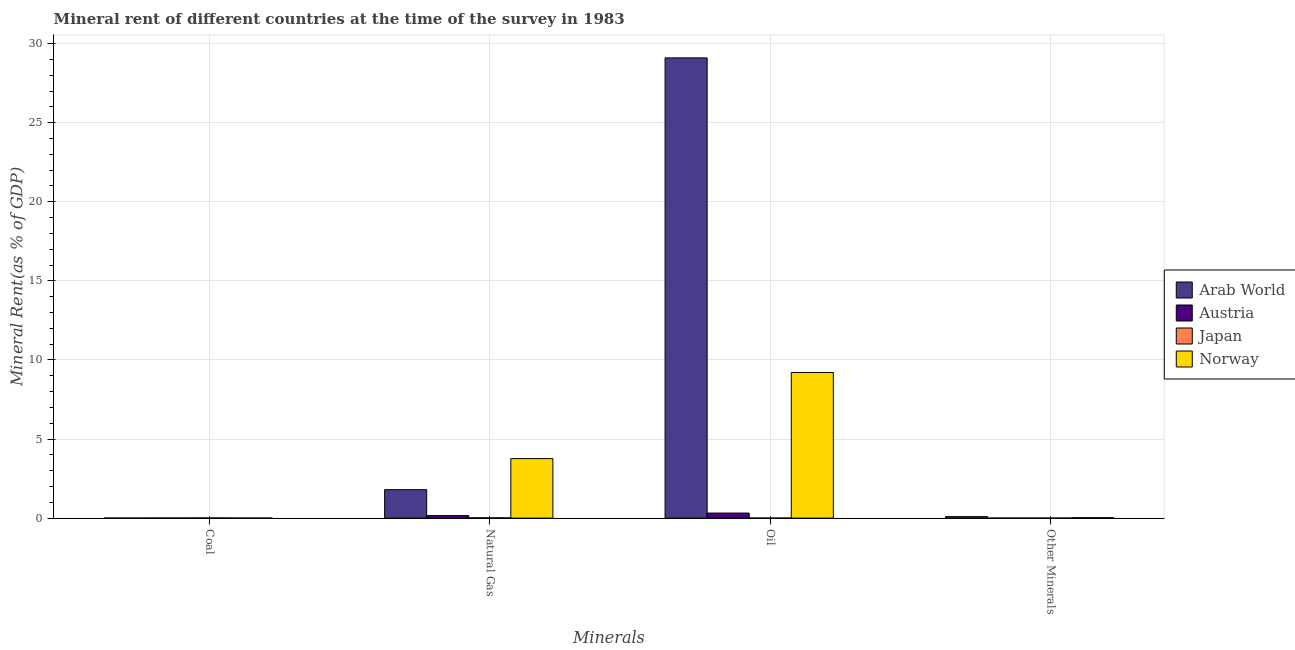How many groups of bars are there?
Give a very brief answer. 4. Are the number of bars on each tick of the X-axis equal?
Give a very brief answer. Yes. How many bars are there on the 1st tick from the right?
Offer a terse response. 4. What is the label of the 4th group of bars from the left?
Your answer should be very brief. Other Minerals. What is the  rent of other minerals in Japan?
Give a very brief answer. 0. Across all countries, what is the maximum oil rent?
Provide a succinct answer. 29.1. Across all countries, what is the minimum  rent of other minerals?
Provide a succinct answer. 0. In which country was the oil rent maximum?
Your answer should be compact. Arab World. What is the total  rent of other minerals in the graph?
Give a very brief answer. 0.13. What is the difference between the oil rent in Japan and that in Arab World?
Offer a very short reply. -29.1. What is the difference between the  rent of other minerals in Arab World and the natural gas rent in Austria?
Give a very brief answer. -0.06. What is the average natural gas rent per country?
Your answer should be very brief. 1.43. What is the difference between the natural gas rent and coal rent in Norway?
Offer a terse response. 3.76. In how many countries, is the  rent of other minerals greater than 1 %?
Give a very brief answer. 0. What is the ratio of the natural gas rent in Japan to that in Arab World?
Offer a terse response. 0.01. Is the difference between the natural gas rent in Norway and Arab World greater than the difference between the coal rent in Norway and Arab World?
Provide a succinct answer. Yes. What is the difference between the highest and the second highest coal rent?
Your response must be concise. 0. What is the difference between the highest and the lowest oil rent?
Provide a short and direct response. 29.1. How many bars are there?
Give a very brief answer. 16. Are all the bars in the graph horizontal?
Provide a succinct answer. No. Where does the legend appear in the graph?
Make the answer very short. Center right. How many legend labels are there?
Ensure brevity in your answer.  4. How are the legend labels stacked?
Ensure brevity in your answer.  Vertical. What is the title of the graph?
Ensure brevity in your answer.  Mineral rent of different countries at the time of the survey in 1983. What is the label or title of the X-axis?
Offer a very short reply. Minerals. What is the label or title of the Y-axis?
Provide a succinct answer. Mineral Rent(as % of GDP). What is the Mineral Rent(as % of GDP) in Arab World in Coal?
Ensure brevity in your answer.  0. What is the Mineral Rent(as % of GDP) in Austria in Coal?
Ensure brevity in your answer.  0.01. What is the Mineral Rent(as % of GDP) of Japan in Coal?
Ensure brevity in your answer.  0.01. What is the Mineral Rent(as % of GDP) of Norway in Coal?
Ensure brevity in your answer.  0. What is the Mineral Rent(as % of GDP) of Arab World in Natural Gas?
Provide a short and direct response. 1.8. What is the Mineral Rent(as % of GDP) in Austria in Natural Gas?
Give a very brief answer. 0.16. What is the Mineral Rent(as % of GDP) in Japan in Natural Gas?
Provide a succinct answer. 0.02. What is the Mineral Rent(as % of GDP) of Norway in Natural Gas?
Make the answer very short. 3.76. What is the Mineral Rent(as % of GDP) of Arab World in Oil?
Give a very brief answer. 29.1. What is the Mineral Rent(as % of GDP) of Austria in Oil?
Offer a very short reply. 0.32. What is the Mineral Rent(as % of GDP) of Japan in Oil?
Provide a succinct answer. 0. What is the Mineral Rent(as % of GDP) in Norway in Oil?
Provide a succinct answer. 9.21. What is the Mineral Rent(as % of GDP) of Arab World in Other Minerals?
Make the answer very short. 0.1. What is the Mineral Rent(as % of GDP) in Austria in Other Minerals?
Provide a short and direct response. 0. What is the Mineral Rent(as % of GDP) of Japan in Other Minerals?
Your response must be concise. 0. What is the Mineral Rent(as % of GDP) of Norway in Other Minerals?
Your response must be concise. 0.03. Across all Minerals, what is the maximum Mineral Rent(as % of GDP) of Arab World?
Your answer should be compact. 29.1. Across all Minerals, what is the maximum Mineral Rent(as % of GDP) in Austria?
Offer a very short reply. 0.32. Across all Minerals, what is the maximum Mineral Rent(as % of GDP) in Japan?
Give a very brief answer. 0.02. Across all Minerals, what is the maximum Mineral Rent(as % of GDP) of Norway?
Provide a short and direct response. 9.21. Across all Minerals, what is the minimum Mineral Rent(as % of GDP) in Arab World?
Ensure brevity in your answer.  0. Across all Minerals, what is the minimum Mineral Rent(as % of GDP) of Austria?
Offer a terse response. 0. Across all Minerals, what is the minimum Mineral Rent(as % of GDP) of Japan?
Give a very brief answer. 0. Across all Minerals, what is the minimum Mineral Rent(as % of GDP) of Norway?
Provide a short and direct response. 0. What is the total Mineral Rent(as % of GDP) in Arab World in the graph?
Keep it short and to the point. 31. What is the total Mineral Rent(as % of GDP) in Austria in the graph?
Your answer should be compact. 0.49. What is the total Mineral Rent(as % of GDP) in Japan in the graph?
Ensure brevity in your answer.  0.04. What is the total Mineral Rent(as % of GDP) in Norway in the graph?
Offer a terse response. 13. What is the difference between the Mineral Rent(as % of GDP) of Arab World in Coal and that in Natural Gas?
Offer a terse response. -1.8. What is the difference between the Mineral Rent(as % of GDP) of Austria in Coal and that in Natural Gas?
Your response must be concise. -0.15. What is the difference between the Mineral Rent(as % of GDP) in Japan in Coal and that in Natural Gas?
Offer a very short reply. -0.01. What is the difference between the Mineral Rent(as % of GDP) of Norway in Coal and that in Natural Gas?
Ensure brevity in your answer.  -3.76. What is the difference between the Mineral Rent(as % of GDP) in Arab World in Coal and that in Oil?
Your answer should be very brief. -29.1. What is the difference between the Mineral Rent(as % of GDP) in Austria in Coal and that in Oil?
Keep it short and to the point. -0.31. What is the difference between the Mineral Rent(as % of GDP) in Japan in Coal and that in Oil?
Provide a short and direct response. 0.01. What is the difference between the Mineral Rent(as % of GDP) of Norway in Coal and that in Oil?
Make the answer very short. -9.2. What is the difference between the Mineral Rent(as % of GDP) in Arab World in Coal and that in Other Minerals?
Your answer should be very brief. -0.09. What is the difference between the Mineral Rent(as % of GDP) in Austria in Coal and that in Other Minerals?
Offer a terse response. 0. What is the difference between the Mineral Rent(as % of GDP) in Japan in Coal and that in Other Minerals?
Provide a short and direct response. 0.01. What is the difference between the Mineral Rent(as % of GDP) of Norway in Coal and that in Other Minerals?
Your response must be concise. -0.02. What is the difference between the Mineral Rent(as % of GDP) of Arab World in Natural Gas and that in Oil?
Your answer should be very brief. -27.3. What is the difference between the Mineral Rent(as % of GDP) in Austria in Natural Gas and that in Oil?
Your response must be concise. -0.16. What is the difference between the Mineral Rent(as % of GDP) in Japan in Natural Gas and that in Oil?
Offer a terse response. 0.01. What is the difference between the Mineral Rent(as % of GDP) of Norway in Natural Gas and that in Oil?
Make the answer very short. -5.45. What is the difference between the Mineral Rent(as % of GDP) in Arab World in Natural Gas and that in Other Minerals?
Offer a terse response. 1.7. What is the difference between the Mineral Rent(as % of GDP) in Austria in Natural Gas and that in Other Minerals?
Provide a succinct answer. 0.16. What is the difference between the Mineral Rent(as % of GDP) in Japan in Natural Gas and that in Other Minerals?
Your answer should be very brief. 0.01. What is the difference between the Mineral Rent(as % of GDP) of Norway in Natural Gas and that in Other Minerals?
Offer a very short reply. 3.73. What is the difference between the Mineral Rent(as % of GDP) of Arab World in Oil and that in Other Minerals?
Offer a very short reply. 29. What is the difference between the Mineral Rent(as % of GDP) of Austria in Oil and that in Other Minerals?
Provide a succinct answer. 0.32. What is the difference between the Mineral Rent(as % of GDP) in Japan in Oil and that in Other Minerals?
Your answer should be very brief. -0. What is the difference between the Mineral Rent(as % of GDP) of Norway in Oil and that in Other Minerals?
Your answer should be compact. 9.18. What is the difference between the Mineral Rent(as % of GDP) in Arab World in Coal and the Mineral Rent(as % of GDP) in Austria in Natural Gas?
Ensure brevity in your answer.  -0.16. What is the difference between the Mineral Rent(as % of GDP) in Arab World in Coal and the Mineral Rent(as % of GDP) in Japan in Natural Gas?
Offer a very short reply. -0.02. What is the difference between the Mineral Rent(as % of GDP) of Arab World in Coal and the Mineral Rent(as % of GDP) of Norway in Natural Gas?
Make the answer very short. -3.76. What is the difference between the Mineral Rent(as % of GDP) in Austria in Coal and the Mineral Rent(as % of GDP) in Japan in Natural Gas?
Offer a very short reply. -0.01. What is the difference between the Mineral Rent(as % of GDP) in Austria in Coal and the Mineral Rent(as % of GDP) in Norway in Natural Gas?
Give a very brief answer. -3.76. What is the difference between the Mineral Rent(as % of GDP) of Japan in Coal and the Mineral Rent(as % of GDP) of Norway in Natural Gas?
Offer a very short reply. -3.75. What is the difference between the Mineral Rent(as % of GDP) in Arab World in Coal and the Mineral Rent(as % of GDP) in Austria in Oil?
Provide a short and direct response. -0.32. What is the difference between the Mineral Rent(as % of GDP) in Arab World in Coal and the Mineral Rent(as % of GDP) in Japan in Oil?
Your answer should be compact. -0. What is the difference between the Mineral Rent(as % of GDP) in Arab World in Coal and the Mineral Rent(as % of GDP) in Norway in Oil?
Provide a short and direct response. -9.21. What is the difference between the Mineral Rent(as % of GDP) of Austria in Coal and the Mineral Rent(as % of GDP) of Japan in Oil?
Your answer should be compact. 0. What is the difference between the Mineral Rent(as % of GDP) in Austria in Coal and the Mineral Rent(as % of GDP) in Norway in Oil?
Keep it short and to the point. -9.2. What is the difference between the Mineral Rent(as % of GDP) of Japan in Coal and the Mineral Rent(as % of GDP) of Norway in Oil?
Give a very brief answer. -9.2. What is the difference between the Mineral Rent(as % of GDP) of Arab World in Coal and the Mineral Rent(as % of GDP) of Austria in Other Minerals?
Keep it short and to the point. -0. What is the difference between the Mineral Rent(as % of GDP) in Arab World in Coal and the Mineral Rent(as % of GDP) in Japan in Other Minerals?
Your answer should be very brief. -0. What is the difference between the Mineral Rent(as % of GDP) of Arab World in Coal and the Mineral Rent(as % of GDP) of Norway in Other Minerals?
Offer a terse response. -0.03. What is the difference between the Mineral Rent(as % of GDP) in Austria in Coal and the Mineral Rent(as % of GDP) in Japan in Other Minerals?
Offer a very short reply. 0. What is the difference between the Mineral Rent(as % of GDP) in Austria in Coal and the Mineral Rent(as % of GDP) in Norway in Other Minerals?
Your answer should be very brief. -0.02. What is the difference between the Mineral Rent(as % of GDP) of Japan in Coal and the Mineral Rent(as % of GDP) of Norway in Other Minerals?
Your response must be concise. -0.02. What is the difference between the Mineral Rent(as % of GDP) of Arab World in Natural Gas and the Mineral Rent(as % of GDP) of Austria in Oil?
Make the answer very short. 1.48. What is the difference between the Mineral Rent(as % of GDP) in Arab World in Natural Gas and the Mineral Rent(as % of GDP) in Japan in Oil?
Make the answer very short. 1.8. What is the difference between the Mineral Rent(as % of GDP) in Arab World in Natural Gas and the Mineral Rent(as % of GDP) in Norway in Oil?
Offer a terse response. -7.41. What is the difference between the Mineral Rent(as % of GDP) in Austria in Natural Gas and the Mineral Rent(as % of GDP) in Japan in Oil?
Provide a succinct answer. 0.16. What is the difference between the Mineral Rent(as % of GDP) in Austria in Natural Gas and the Mineral Rent(as % of GDP) in Norway in Oil?
Offer a terse response. -9.05. What is the difference between the Mineral Rent(as % of GDP) of Japan in Natural Gas and the Mineral Rent(as % of GDP) of Norway in Oil?
Offer a terse response. -9.19. What is the difference between the Mineral Rent(as % of GDP) in Arab World in Natural Gas and the Mineral Rent(as % of GDP) in Austria in Other Minerals?
Your answer should be very brief. 1.8. What is the difference between the Mineral Rent(as % of GDP) of Arab World in Natural Gas and the Mineral Rent(as % of GDP) of Japan in Other Minerals?
Make the answer very short. 1.8. What is the difference between the Mineral Rent(as % of GDP) in Arab World in Natural Gas and the Mineral Rent(as % of GDP) in Norway in Other Minerals?
Ensure brevity in your answer.  1.77. What is the difference between the Mineral Rent(as % of GDP) of Austria in Natural Gas and the Mineral Rent(as % of GDP) of Japan in Other Minerals?
Your answer should be very brief. 0.16. What is the difference between the Mineral Rent(as % of GDP) in Austria in Natural Gas and the Mineral Rent(as % of GDP) in Norway in Other Minerals?
Offer a very short reply. 0.13. What is the difference between the Mineral Rent(as % of GDP) in Japan in Natural Gas and the Mineral Rent(as % of GDP) in Norway in Other Minerals?
Offer a very short reply. -0.01. What is the difference between the Mineral Rent(as % of GDP) of Arab World in Oil and the Mineral Rent(as % of GDP) of Austria in Other Minerals?
Make the answer very short. 29.1. What is the difference between the Mineral Rent(as % of GDP) in Arab World in Oil and the Mineral Rent(as % of GDP) in Japan in Other Minerals?
Make the answer very short. 29.1. What is the difference between the Mineral Rent(as % of GDP) of Arab World in Oil and the Mineral Rent(as % of GDP) of Norway in Other Minerals?
Ensure brevity in your answer.  29.07. What is the difference between the Mineral Rent(as % of GDP) in Austria in Oil and the Mineral Rent(as % of GDP) in Japan in Other Minerals?
Give a very brief answer. 0.32. What is the difference between the Mineral Rent(as % of GDP) of Austria in Oil and the Mineral Rent(as % of GDP) of Norway in Other Minerals?
Keep it short and to the point. 0.29. What is the difference between the Mineral Rent(as % of GDP) of Japan in Oil and the Mineral Rent(as % of GDP) of Norway in Other Minerals?
Make the answer very short. -0.03. What is the average Mineral Rent(as % of GDP) of Arab World per Minerals?
Keep it short and to the point. 7.75. What is the average Mineral Rent(as % of GDP) in Austria per Minerals?
Provide a short and direct response. 0.12. What is the average Mineral Rent(as % of GDP) of Japan per Minerals?
Your response must be concise. 0.01. What is the average Mineral Rent(as % of GDP) in Norway per Minerals?
Make the answer very short. 3.25. What is the difference between the Mineral Rent(as % of GDP) in Arab World and Mineral Rent(as % of GDP) in Austria in Coal?
Ensure brevity in your answer.  -0.01. What is the difference between the Mineral Rent(as % of GDP) of Arab World and Mineral Rent(as % of GDP) of Japan in Coal?
Offer a terse response. -0.01. What is the difference between the Mineral Rent(as % of GDP) in Arab World and Mineral Rent(as % of GDP) in Norway in Coal?
Offer a very short reply. -0. What is the difference between the Mineral Rent(as % of GDP) in Austria and Mineral Rent(as % of GDP) in Japan in Coal?
Offer a terse response. -0. What is the difference between the Mineral Rent(as % of GDP) in Austria and Mineral Rent(as % of GDP) in Norway in Coal?
Offer a terse response. 0. What is the difference between the Mineral Rent(as % of GDP) in Japan and Mineral Rent(as % of GDP) in Norway in Coal?
Provide a succinct answer. 0.01. What is the difference between the Mineral Rent(as % of GDP) in Arab World and Mineral Rent(as % of GDP) in Austria in Natural Gas?
Make the answer very short. 1.64. What is the difference between the Mineral Rent(as % of GDP) in Arab World and Mineral Rent(as % of GDP) in Japan in Natural Gas?
Your response must be concise. 1.78. What is the difference between the Mineral Rent(as % of GDP) in Arab World and Mineral Rent(as % of GDP) in Norway in Natural Gas?
Provide a short and direct response. -1.96. What is the difference between the Mineral Rent(as % of GDP) in Austria and Mineral Rent(as % of GDP) in Japan in Natural Gas?
Offer a very short reply. 0.14. What is the difference between the Mineral Rent(as % of GDP) in Austria and Mineral Rent(as % of GDP) in Norway in Natural Gas?
Ensure brevity in your answer.  -3.6. What is the difference between the Mineral Rent(as % of GDP) of Japan and Mineral Rent(as % of GDP) of Norway in Natural Gas?
Ensure brevity in your answer.  -3.74. What is the difference between the Mineral Rent(as % of GDP) in Arab World and Mineral Rent(as % of GDP) in Austria in Oil?
Offer a terse response. 28.78. What is the difference between the Mineral Rent(as % of GDP) in Arab World and Mineral Rent(as % of GDP) in Japan in Oil?
Offer a terse response. 29.1. What is the difference between the Mineral Rent(as % of GDP) of Arab World and Mineral Rent(as % of GDP) of Norway in Oil?
Give a very brief answer. 19.89. What is the difference between the Mineral Rent(as % of GDP) in Austria and Mineral Rent(as % of GDP) in Japan in Oil?
Provide a succinct answer. 0.32. What is the difference between the Mineral Rent(as % of GDP) in Austria and Mineral Rent(as % of GDP) in Norway in Oil?
Keep it short and to the point. -8.89. What is the difference between the Mineral Rent(as % of GDP) of Japan and Mineral Rent(as % of GDP) of Norway in Oil?
Make the answer very short. -9.21. What is the difference between the Mineral Rent(as % of GDP) in Arab World and Mineral Rent(as % of GDP) in Austria in Other Minerals?
Keep it short and to the point. 0.09. What is the difference between the Mineral Rent(as % of GDP) of Arab World and Mineral Rent(as % of GDP) of Japan in Other Minerals?
Your answer should be compact. 0.09. What is the difference between the Mineral Rent(as % of GDP) in Arab World and Mineral Rent(as % of GDP) in Norway in Other Minerals?
Your response must be concise. 0.07. What is the difference between the Mineral Rent(as % of GDP) in Austria and Mineral Rent(as % of GDP) in Japan in Other Minerals?
Ensure brevity in your answer.  -0. What is the difference between the Mineral Rent(as % of GDP) of Austria and Mineral Rent(as % of GDP) of Norway in Other Minerals?
Offer a terse response. -0.03. What is the difference between the Mineral Rent(as % of GDP) of Japan and Mineral Rent(as % of GDP) of Norway in Other Minerals?
Provide a succinct answer. -0.03. What is the ratio of the Mineral Rent(as % of GDP) of Arab World in Coal to that in Natural Gas?
Make the answer very short. 0. What is the ratio of the Mineral Rent(as % of GDP) in Austria in Coal to that in Natural Gas?
Your response must be concise. 0.04. What is the ratio of the Mineral Rent(as % of GDP) in Japan in Coal to that in Natural Gas?
Keep it short and to the point. 0.53. What is the ratio of the Mineral Rent(as % of GDP) of Norway in Coal to that in Natural Gas?
Keep it short and to the point. 0. What is the ratio of the Mineral Rent(as % of GDP) in Arab World in Coal to that in Oil?
Give a very brief answer. 0. What is the ratio of the Mineral Rent(as % of GDP) of Austria in Coal to that in Oil?
Keep it short and to the point. 0.02. What is the ratio of the Mineral Rent(as % of GDP) in Japan in Coal to that in Oil?
Your answer should be very brief. 2.89. What is the ratio of the Mineral Rent(as % of GDP) of Norway in Coal to that in Oil?
Offer a terse response. 0. What is the ratio of the Mineral Rent(as % of GDP) in Arab World in Coal to that in Other Minerals?
Your response must be concise. 0.02. What is the ratio of the Mineral Rent(as % of GDP) in Austria in Coal to that in Other Minerals?
Give a very brief answer. 2.16. What is the ratio of the Mineral Rent(as % of GDP) of Japan in Coal to that in Other Minerals?
Offer a very short reply. 2.3. What is the ratio of the Mineral Rent(as % of GDP) of Norway in Coal to that in Other Minerals?
Your answer should be compact. 0.15. What is the ratio of the Mineral Rent(as % of GDP) in Arab World in Natural Gas to that in Oil?
Your answer should be compact. 0.06. What is the ratio of the Mineral Rent(as % of GDP) in Austria in Natural Gas to that in Oil?
Your answer should be very brief. 0.5. What is the ratio of the Mineral Rent(as % of GDP) in Japan in Natural Gas to that in Oil?
Offer a very short reply. 5.48. What is the ratio of the Mineral Rent(as % of GDP) of Norway in Natural Gas to that in Oil?
Offer a terse response. 0.41. What is the ratio of the Mineral Rent(as % of GDP) in Arab World in Natural Gas to that in Other Minerals?
Make the answer very short. 18.92. What is the ratio of the Mineral Rent(as % of GDP) in Austria in Natural Gas to that in Other Minerals?
Give a very brief answer. 50.79. What is the ratio of the Mineral Rent(as % of GDP) of Japan in Natural Gas to that in Other Minerals?
Provide a succinct answer. 4.36. What is the ratio of the Mineral Rent(as % of GDP) of Norway in Natural Gas to that in Other Minerals?
Ensure brevity in your answer.  129. What is the ratio of the Mineral Rent(as % of GDP) in Arab World in Oil to that in Other Minerals?
Your answer should be compact. 305.95. What is the ratio of the Mineral Rent(as % of GDP) in Austria in Oil to that in Other Minerals?
Keep it short and to the point. 101.72. What is the ratio of the Mineral Rent(as % of GDP) in Japan in Oil to that in Other Minerals?
Your response must be concise. 0.8. What is the ratio of the Mineral Rent(as % of GDP) of Norway in Oil to that in Other Minerals?
Provide a succinct answer. 315.74. What is the difference between the highest and the second highest Mineral Rent(as % of GDP) of Arab World?
Give a very brief answer. 27.3. What is the difference between the highest and the second highest Mineral Rent(as % of GDP) in Austria?
Provide a short and direct response. 0.16. What is the difference between the highest and the second highest Mineral Rent(as % of GDP) of Japan?
Keep it short and to the point. 0.01. What is the difference between the highest and the second highest Mineral Rent(as % of GDP) in Norway?
Ensure brevity in your answer.  5.45. What is the difference between the highest and the lowest Mineral Rent(as % of GDP) of Arab World?
Give a very brief answer. 29.1. What is the difference between the highest and the lowest Mineral Rent(as % of GDP) in Austria?
Your answer should be very brief. 0.32. What is the difference between the highest and the lowest Mineral Rent(as % of GDP) of Japan?
Make the answer very short. 0.01. What is the difference between the highest and the lowest Mineral Rent(as % of GDP) in Norway?
Offer a very short reply. 9.2. 